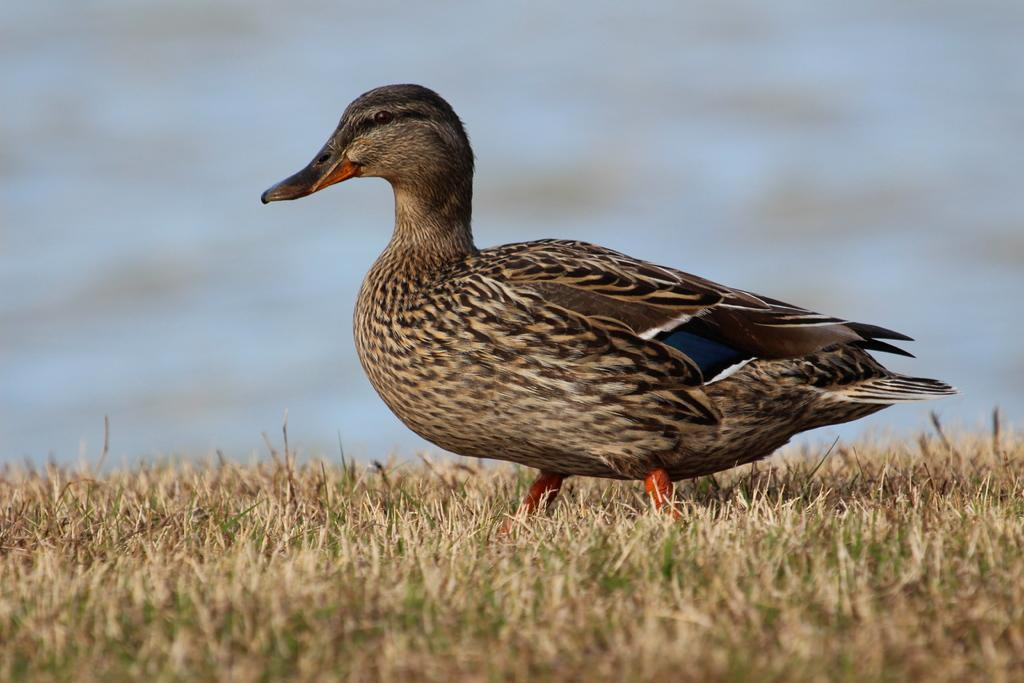What animal is in the foreground of the image? There is a duck in the foreground of the image. What is the duck standing on? The duck is on the grass. Can you describe the background of the image? The background of the image is blurred. What type of legal advice is the duck providing in the image? There is no indication in the image that the duck is providing legal advice, as ducks do not have the ability to provide legal advice. 